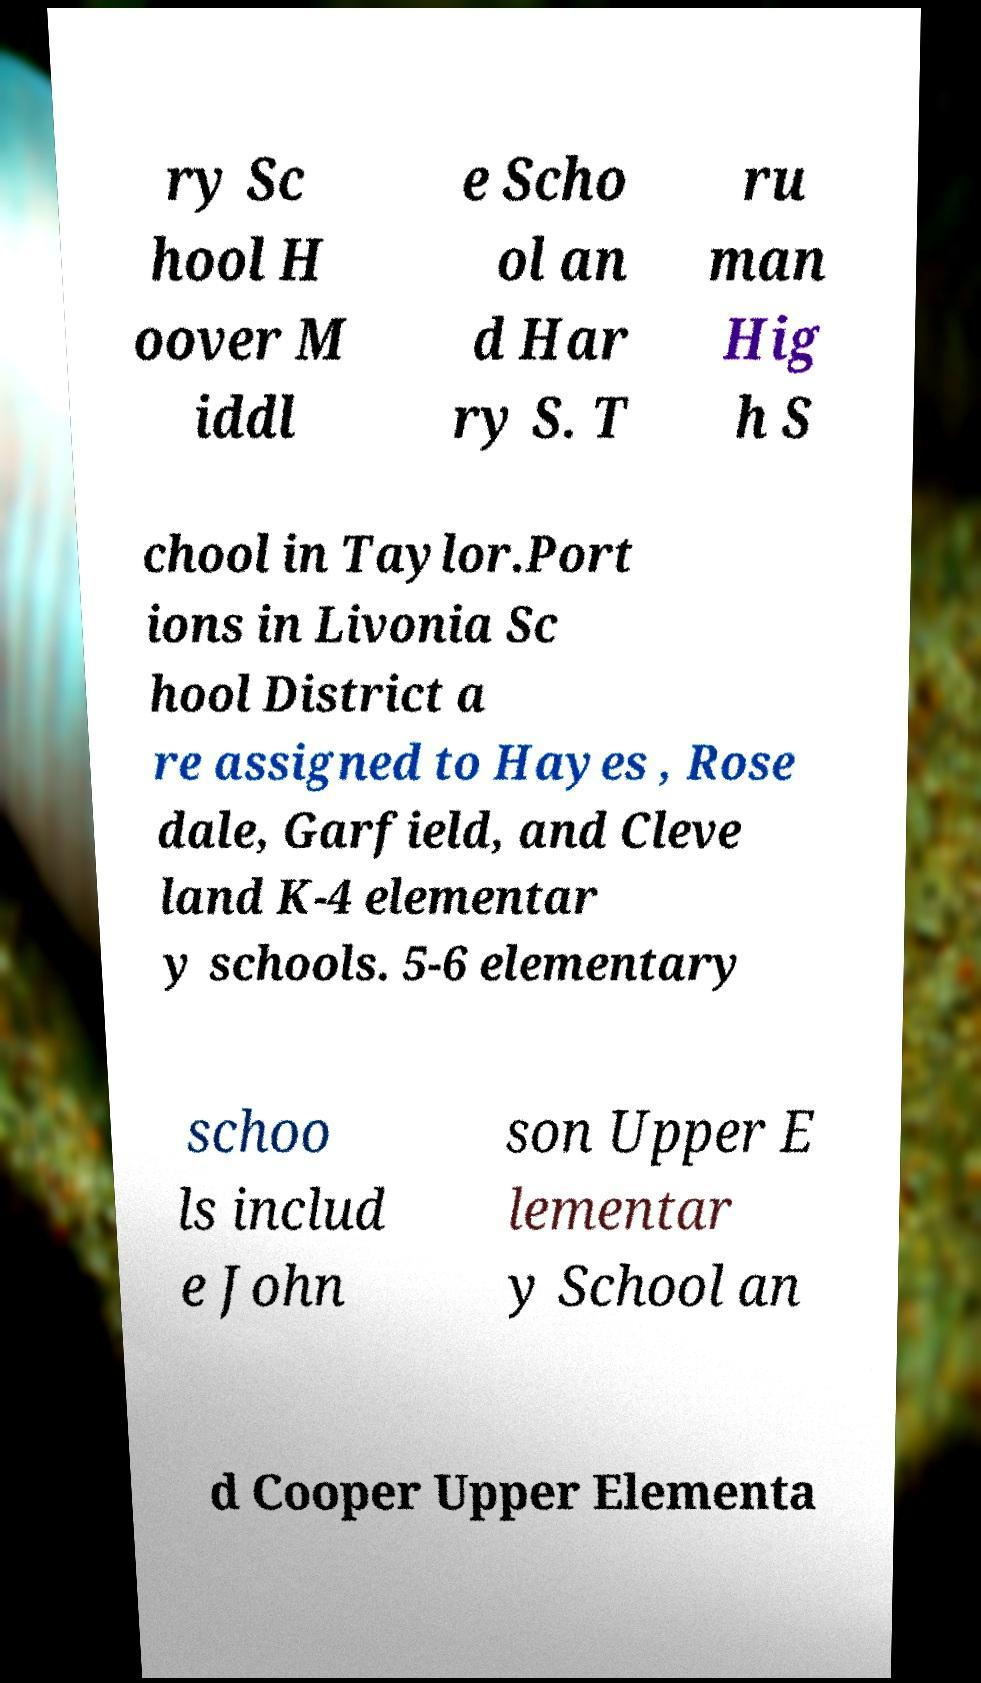Could you assist in decoding the text presented in this image and type it out clearly? ry Sc hool H oover M iddl e Scho ol an d Har ry S. T ru man Hig h S chool in Taylor.Port ions in Livonia Sc hool District a re assigned to Hayes , Rose dale, Garfield, and Cleve land K-4 elementar y schools. 5-6 elementary schoo ls includ e John son Upper E lementar y School an d Cooper Upper Elementa 